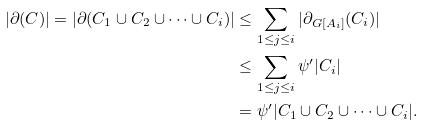<formula> <loc_0><loc_0><loc_500><loc_500>| \partial ( C ) | = | \partial ( C _ { 1 } \cup C _ { 2 } \cup \cdots \cup C _ { i } ) | & \leq \sum _ { 1 \leq j \leq i } | \partial _ { G [ A _ { i } ] } ( C _ { i } ) | \\ & \leq \sum _ { 1 \leq j \leq i } \psi ^ { \prime } | C _ { i } | \\ & = \psi ^ { \prime } | C _ { 1 } \cup C _ { 2 } \cup \cdots \cup C _ { i } | .</formula> 